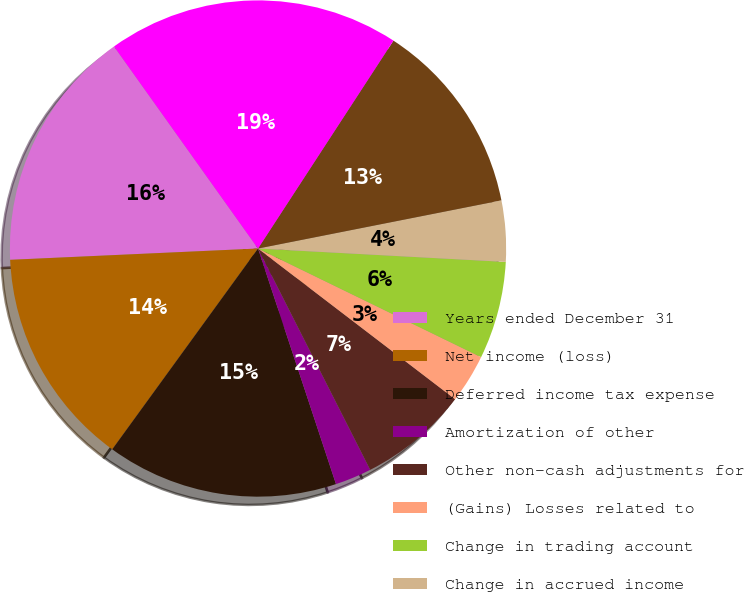Convert chart to OTSL. <chart><loc_0><loc_0><loc_500><loc_500><pie_chart><fcel>Years ended December 31<fcel>Net income (loss)<fcel>Deferred income tax expense<fcel>Amortization of other<fcel>Other non-cash adjustments for<fcel>(Gains) Losses related to<fcel>Change in trading account<fcel>Change in accrued income<fcel>Change in collateral deposits<fcel>Other net<nl><fcel>15.87%<fcel>14.28%<fcel>15.08%<fcel>2.38%<fcel>7.14%<fcel>3.18%<fcel>6.35%<fcel>3.97%<fcel>12.7%<fcel>19.04%<nl></chart> 